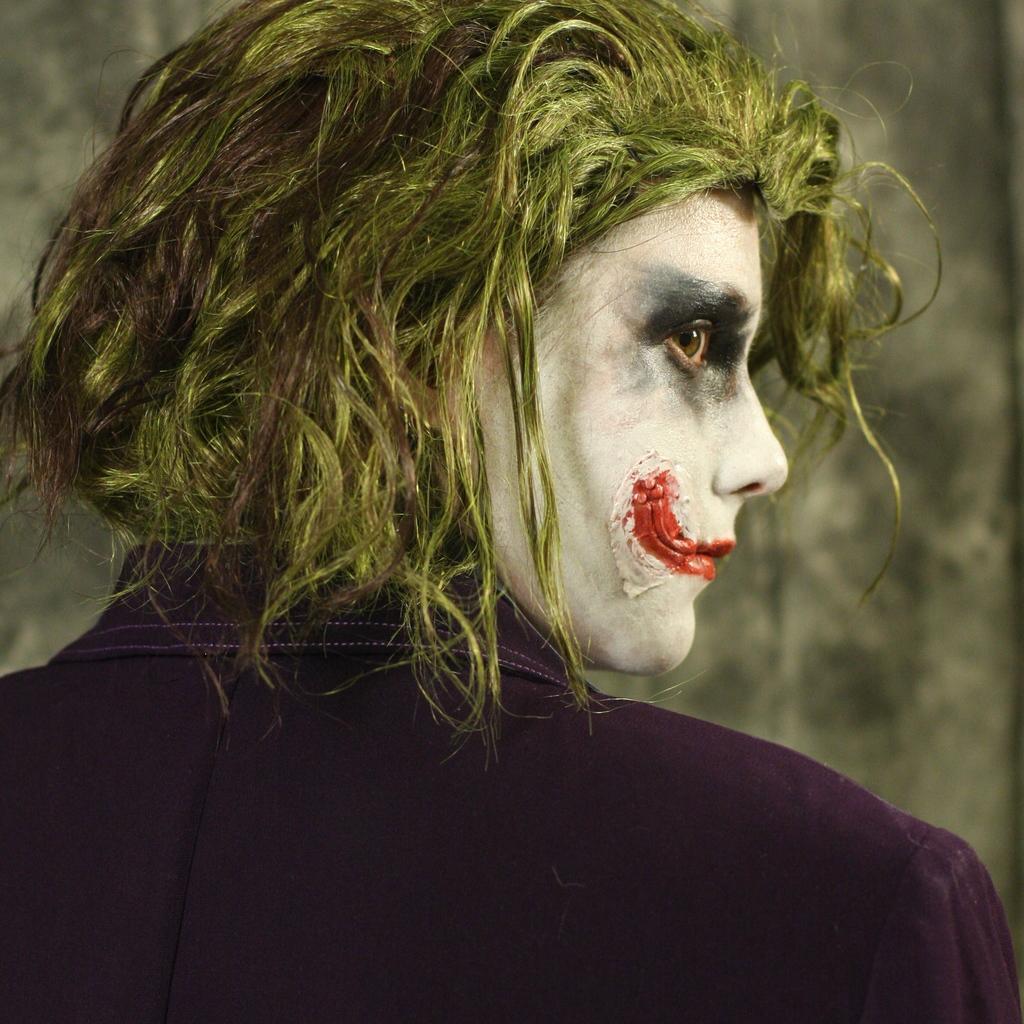Please provide a concise description of this image. This image consists of a man wearing jokers costume. In the background, there is a wall. He is wearing a purple color coat. 